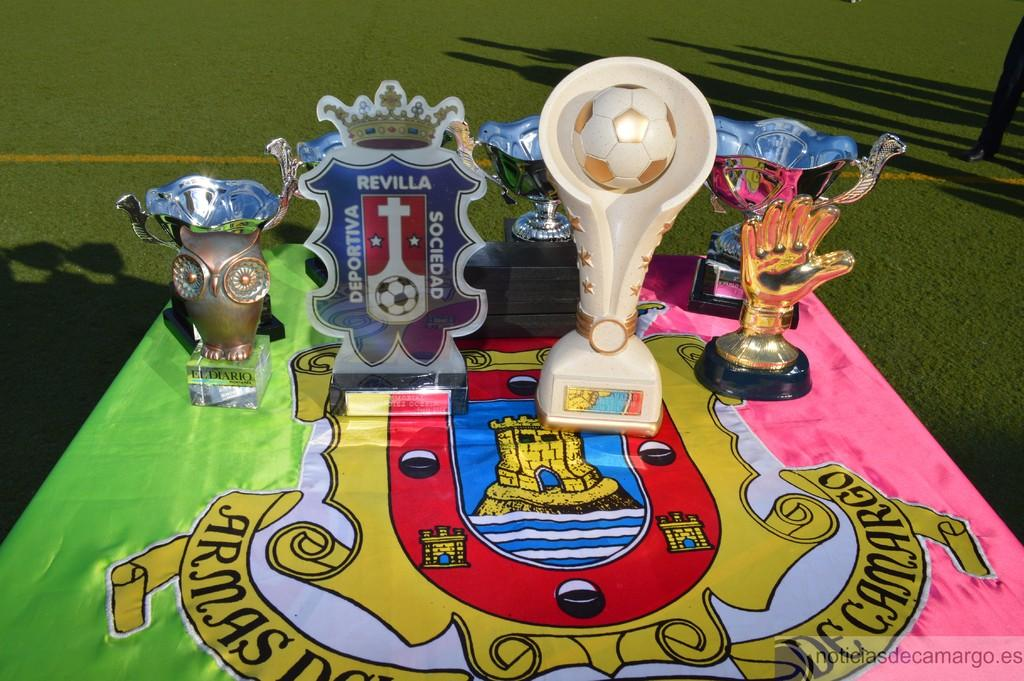Provide a one-sentence caption for the provided image. Four trophies placed on a table outdoors with one trophy saying "Revilla". 